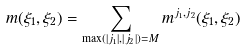Convert formula to latex. <formula><loc_0><loc_0><loc_500><loc_500>m ( \xi _ { 1 } , \xi _ { 2 } ) = \sum _ { \max ( | j _ { 1 } | , | j _ { 2 } | ) = M } m ^ { j _ { 1 } , j _ { 2 } } ( \xi _ { 1 } , \xi _ { 2 } )</formula> 